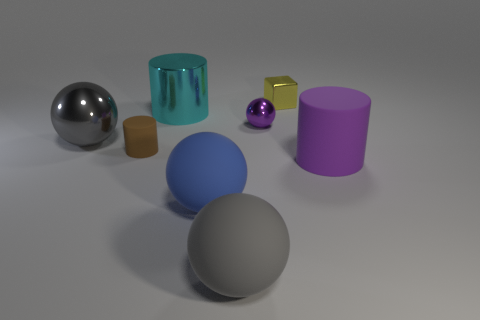Subtract all large cyan metallic cylinders. How many cylinders are left? 2 Subtract all gray spheres. How many spheres are left? 2 Subtract all cylinders. How many objects are left? 5 Subtract 2 cylinders. How many cylinders are left? 1 Subtract all green blocks. Subtract all cyan cylinders. How many blocks are left? 1 Subtract all brown spheres. How many cyan cylinders are left? 1 Subtract all purple rubber objects. Subtract all gray metal objects. How many objects are left? 6 Add 3 big cyan metal cylinders. How many big cyan metal cylinders are left? 4 Add 7 brown cylinders. How many brown cylinders exist? 8 Add 2 metallic balls. How many objects exist? 10 